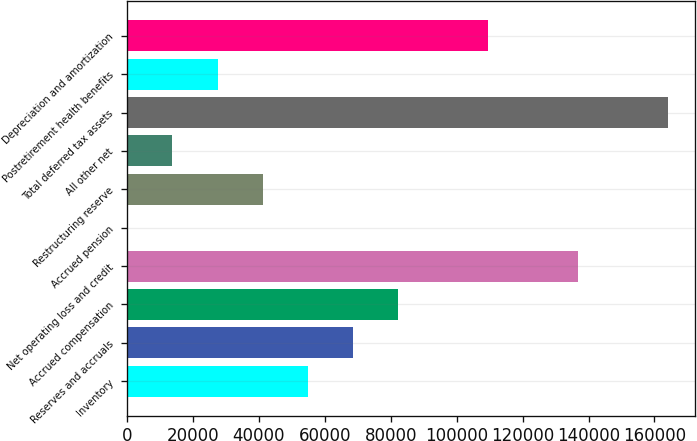Convert chart to OTSL. <chart><loc_0><loc_0><loc_500><loc_500><bar_chart><fcel>Inventory<fcel>Reserves and accruals<fcel>Accrued compensation<fcel>Net operating loss and credit<fcel>Accrued pension<fcel>Restructuring reserve<fcel>All other net<fcel>Total deferred tax assets<fcel>Postretirement health benefits<fcel>Depreciation and amortization<nl><fcel>54791<fcel>68468<fcel>82145<fcel>136853<fcel>83<fcel>41114<fcel>13760<fcel>164207<fcel>27437<fcel>109499<nl></chart> 